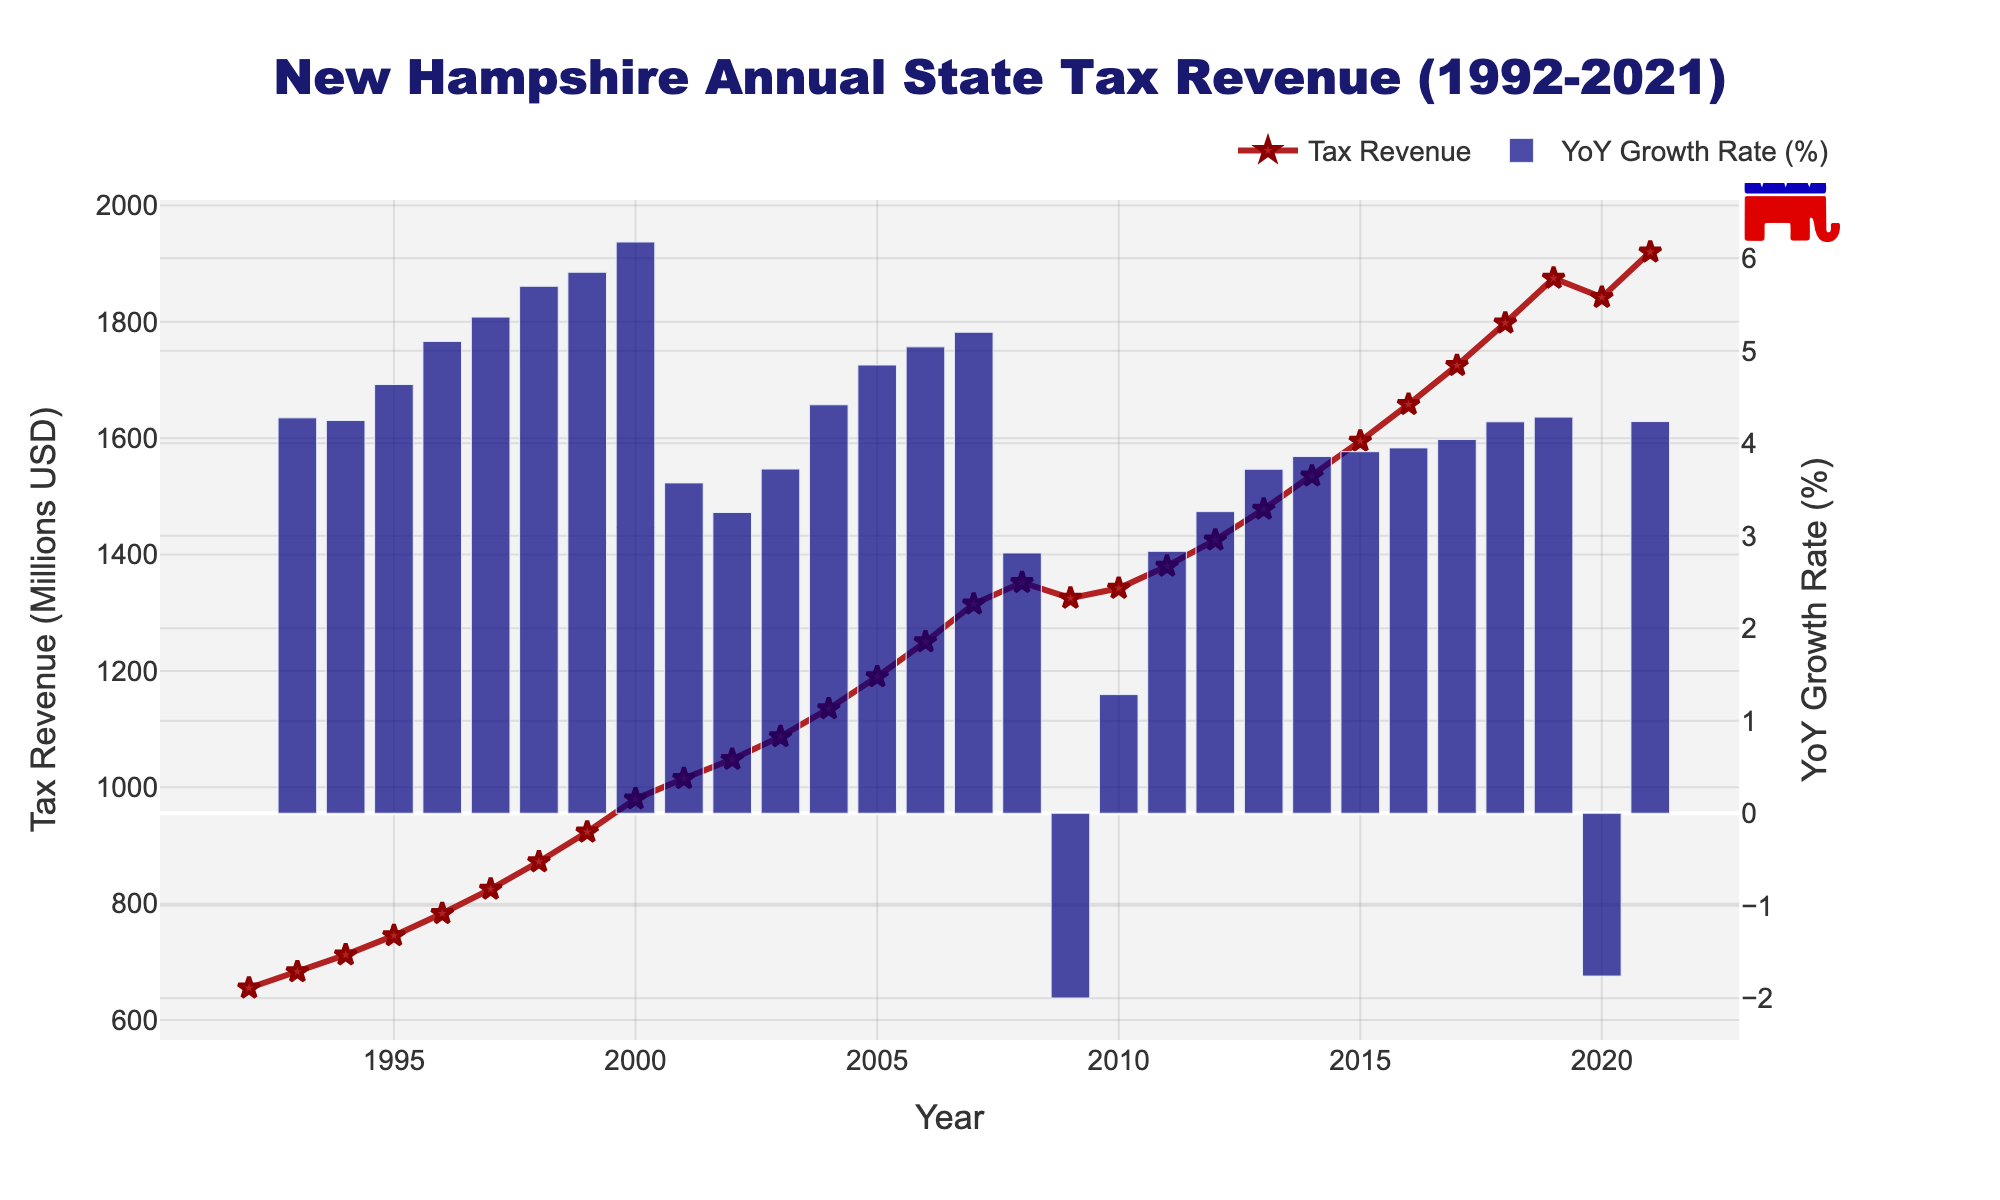What was the total tax revenue generated over the entire 30-year period? To determine the total tax revenue over the period, sum the tax revenue from each year. The data provides annual tax revenue figures, and summing these gives the total tax revenue.
Answer: 37,426 million USD In which year did the tax revenue experience the highest year-over-year growth rate? Evaluate the year-over-year growth rate for each year by examining the secondary bar plot. Identify the year with the highest bar value.
Answer: 1999 How much did the tax revenue increase from the year 2000 to 2021? Subtract the tax revenue in 2000 from the tax revenue in 2021 to find the increase. Tax Revenue in 2000 was 980 million USD, and in 2021 it was 1920 million USD. So, 1920 - 980 = 940.
Answer: 940 million USD What is the average annual tax revenue for the decade of the 2010s (2010-2019)? Calculate the average by summing the tax revenue from 2010 to 2019 and then dividing by the number of years (10). Sum = 1342 + 1380 + 1425 + 1478 + 1535 + 1595 + 1658 + 1725 + 1798 + 1875 = 15711. Average = 15711 / 10 = 1571.1.
Answer: 1571.1 million USD During which years did the tax revenue decrease compared to the previous year? Look at the line graph and identify the years where there is a downward slope. These years are 2009 and 2020.
Answer: 2009, 2020 What is the overall trend observed in the annual state tax revenue from 1992 to 2021? The visual trend from the line graph shows an overall increasing trajectory with occasional slight dips, especially notable in 2009 and 2020.
Answer: Increasing Which year had the highest tax revenue between 1992 and 2021? Identify the highest point on the line graph representing tax revenue. This highest point corresponds to the year 2021.
Answer: 2021 How did the tax revenue in 2008 compare to that in 2009? Compare the values: Tax revenue in 2008 was 1352 million USD, and in 2009, it was 1325 million USD. 2009 saw a decrease.
Answer: 2008 was higher What is the median annual tax revenue from 1992 to 2021? To find the median, list all 30 years' tax revenues in ascending order and find the middle value. With 30 values, the median is the average of the 15th and 16th values. Values: (655, 683, 712, 745, 783, 825, 872, 923, 980, 1015, 1048, 1087, 1135, 1190, 1250, 1315, 1325, 1342, 1352, 1380, 1425, 1478, 1535, 1595, 1658, 1725, 1798, 1842, 1875, 1920). 15th value = 1250, 16th value = 1315. Median = (1250 + 1315) / 2 = 1282.5.
Answer: 1282.5 million USD 